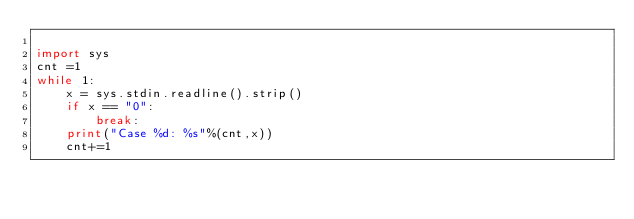<code> <loc_0><loc_0><loc_500><loc_500><_Python_>
import sys 
cnt =1
while 1:
    x = sys.stdin.readline().strip()
    if x == "0":
        break:
    print("Case %d: %s"%(cnt,x))
    cnt+=1</code> 